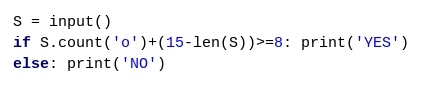Convert code to text. <code><loc_0><loc_0><loc_500><loc_500><_Python_>S = input()
if S.count('o')+(15-len(S))>=8: print('YES')
else: print('NO')</code> 